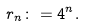<formula> <loc_0><loc_0><loc_500><loc_500>r _ { n } \colon = 4 ^ { n } .</formula> 